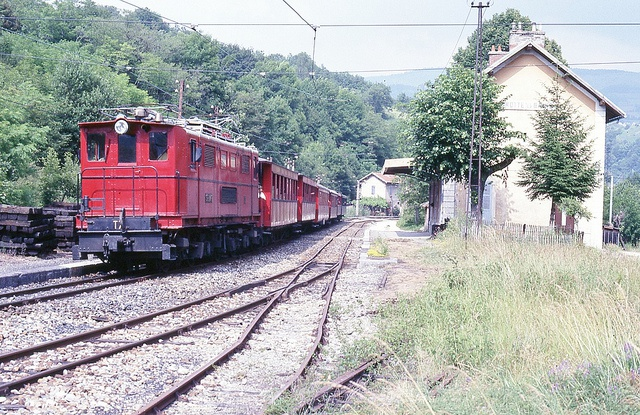Describe the objects in this image and their specific colors. I can see a train in gray, black, salmon, and purple tones in this image. 